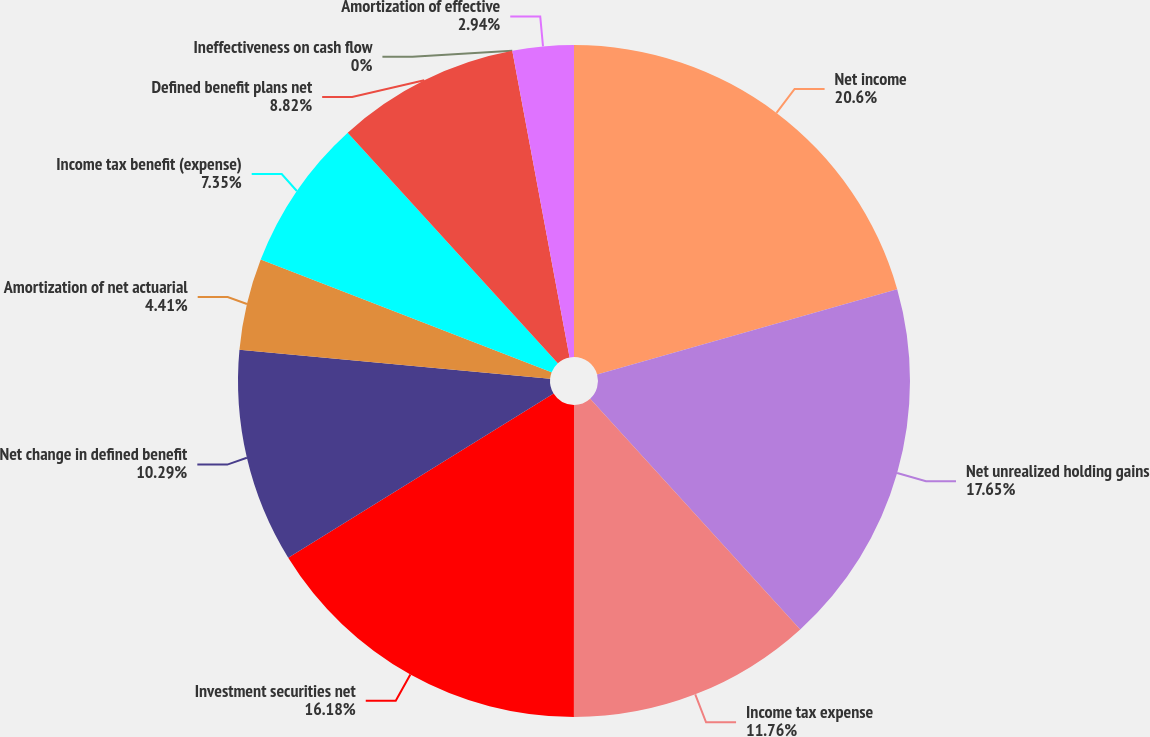Convert chart to OTSL. <chart><loc_0><loc_0><loc_500><loc_500><pie_chart><fcel>Net income<fcel>Net unrealized holding gains<fcel>Income tax expense<fcel>Investment securities net<fcel>Net change in defined benefit<fcel>Amortization of net actuarial<fcel>Income tax benefit (expense)<fcel>Defined benefit plans net<fcel>Ineffectiveness on cash flow<fcel>Amortization of effective<nl><fcel>20.59%<fcel>17.65%<fcel>11.76%<fcel>16.18%<fcel>10.29%<fcel>4.41%<fcel>7.35%<fcel>8.82%<fcel>0.0%<fcel>2.94%<nl></chart> 